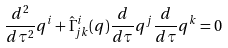<formula> <loc_0><loc_0><loc_500><loc_500>\frac { d ^ { 2 } } { d \tau ^ { 2 } } { q } ^ { i } + \hat { \Gamma } ^ { i } _ { j k } ( q ) \frac { d } { d \tau } { q } ^ { j } \frac { d } { d \tau } { q } ^ { k } = 0</formula> 